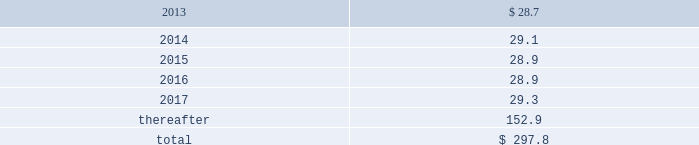Do so , cme invests such contributions in assets that mirror the assumed investment choices .
The balances in these plans are subject to the claims of general creditors of the exchange and totaled $ 38.7 million and $ 31.8 million at december 31 , 2012 and 2011 respectively .
Although the value of the plans is recorded as an asset in marketable securities in the consolidated balance sheets , there is an equal and offsetting liability .
The investment results of these plans have no impact on net income as the investment results are recorded in equal amounts to both investment income and compensation and benefits expense .
Supplemental savings plan .
Cme maintains a supplemental plan to provide benefits for employees who have been impacted by statutory limits under the provisions of the qualified pension and savings plan .
Employees in this plan are subject to the vesting requirements of the underlying qualified plans .
Deferred compensation plan .
A deferred compensation plan is maintained by cme , under which eligible officers and members of the board of directors may contribute a percentage of their compensation and defer income taxes thereon until the time of distribution .
Comex members 2019 retirement plan and benefits .
Comex maintains a retirement and benefit plan under the comex members 2019 recognition and retention plan ( mrrp ) .
This plan provides benefits to certain members of the comex division based on long-term membership , and participation is limited to individuals who were comex division members prior to nymex 2019s acquisition of comex in 1994 .
No new participants were permitted into the plan after the date of this acquisition .
Under the terms of the mrrp , the company is required to fund the plan with a minimum annual contribution of $ 0.8 million until it is fully funded .
All benefits to be paid under the mrrp are based on reasonable actuarial assumptions which are based upon the amounts that are available and are expected to be available to pay benefits .
Total contributions to the plan were $ 0.8 million for each of 2010 through 2012 .
At december 31 , 2012 and 2011 , the obligation for the mrrp totaled $ 22.7 million and $ 21.6 million , respectively .
Assets with a fair value of $ 18.4 million and $ 17.7 million have been allocated to this plan at december 31 , 2012 and 2011 , respectively , and are included in marketable securities and cash and cash equivalents in the consolidated balance sheets .
The balances in these plans are subject to the claims of general creditors of comex .
13 .
Commitments operating leases .
Cme group has entered into various non-cancellable operating lease agreements , with the most significant being as follows : 2022 in april 2012 , the company sold two buildings in chicago at 141 w .
Jackson and leased back a portion of the property .
The operating lease , which has an initial lease term ending on april 30 , 2027 , contains four consecutive renewal options for five years .
2022 in january 2011 , the company entered into an operating lease for office space in london .
The initial lease term , which became effective on january 20 , 2011 , terminates on march 24 , 2026 , with an option to terminate without penalty in january 2021 .
2022 in july 2008 , the company renegotiated the operating lease for its headquarters at 20 south wacker drive in chicago .
The lease , which has an initial term ending on november 30 , 2022 , contains two consecutive renewal options for seven and ten years and a contraction option which allows the company to reduce its occupied space after november 30 , 2018 .
In addition , the company may exercise a lease expansion option in december 2017 .
2022 in august 2006 , the company entered into an operating lease for additional office space in chicago .
The initial lease term , which became effective on august 10 , 2006 , terminates on november 30 , 2023 .
The lease contains two 5-year renewal options beginning in 2023 .
At december 31 , 2012 , future minimum payments under non-cancellable operating leases were payable as follows ( in millions ) : .

What is the percentage increase in obligation for the mrrp from 2011 to 2012? 
Computations: ((22.7 - 21.6) / 21.6)
Answer: 0.05093. Do so , cme invests such contributions in assets that mirror the assumed investment choices .
The balances in these plans are subject to the claims of general creditors of the exchange and totaled $ 38.7 million and $ 31.8 million at december 31 , 2012 and 2011 respectively .
Although the value of the plans is recorded as an asset in marketable securities in the consolidated balance sheets , there is an equal and offsetting liability .
The investment results of these plans have no impact on net income as the investment results are recorded in equal amounts to both investment income and compensation and benefits expense .
Supplemental savings plan .
Cme maintains a supplemental plan to provide benefits for employees who have been impacted by statutory limits under the provisions of the qualified pension and savings plan .
Employees in this plan are subject to the vesting requirements of the underlying qualified plans .
Deferred compensation plan .
A deferred compensation plan is maintained by cme , under which eligible officers and members of the board of directors may contribute a percentage of their compensation and defer income taxes thereon until the time of distribution .
Comex members 2019 retirement plan and benefits .
Comex maintains a retirement and benefit plan under the comex members 2019 recognition and retention plan ( mrrp ) .
This plan provides benefits to certain members of the comex division based on long-term membership , and participation is limited to individuals who were comex division members prior to nymex 2019s acquisition of comex in 1994 .
No new participants were permitted into the plan after the date of this acquisition .
Under the terms of the mrrp , the company is required to fund the plan with a minimum annual contribution of $ 0.8 million until it is fully funded .
All benefits to be paid under the mrrp are based on reasonable actuarial assumptions which are based upon the amounts that are available and are expected to be available to pay benefits .
Total contributions to the plan were $ 0.8 million for each of 2010 through 2012 .
At december 31 , 2012 and 2011 , the obligation for the mrrp totaled $ 22.7 million and $ 21.6 million , respectively .
Assets with a fair value of $ 18.4 million and $ 17.7 million have been allocated to this plan at december 31 , 2012 and 2011 , respectively , and are included in marketable securities and cash and cash equivalents in the consolidated balance sheets .
The balances in these plans are subject to the claims of general creditors of comex .
13 .
Commitments operating leases .
Cme group has entered into various non-cancellable operating lease agreements , with the most significant being as follows : 2022 in april 2012 , the company sold two buildings in chicago at 141 w .
Jackson and leased back a portion of the property .
The operating lease , which has an initial lease term ending on april 30 , 2027 , contains four consecutive renewal options for five years .
2022 in january 2011 , the company entered into an operating lease for office space in london .
The initial lease term , which became effective on january 20 , 2011 , terminates on march 24 , 2026 , with an option to terminate without penalty in january 2021 .
2022 in july 2008 , the company renegotiated the operating lease for its headquarters at 20 south wacker drive in chicago .
The lease , which has an initial term ending on november 30 , 2022 , contains two consecutive renewal options for seven and ten years and a contraction option which allows the company to reduce its occupied space after november 30 , 2018 .
In addition , the company may exercise a lease expansion option in december 2017 .
2022 in august 2006 , the company entered into an operating lease for additional office space in chicago .
The initial lease term , which became effective on august 10 , 2006 , terminates on november 30 , 2023 .
The lease contains two 5-year renewal options beginning in 2023 .
At december 31 , 2012 , future minimum payments under non-cancellable operating leases were payable as follows ( in millions ) : .

What was the ratio of the assets to the obligations of the mrrp in 2012? 
Computations: (18.4 / 22.7)
Answer: 0.81057. 